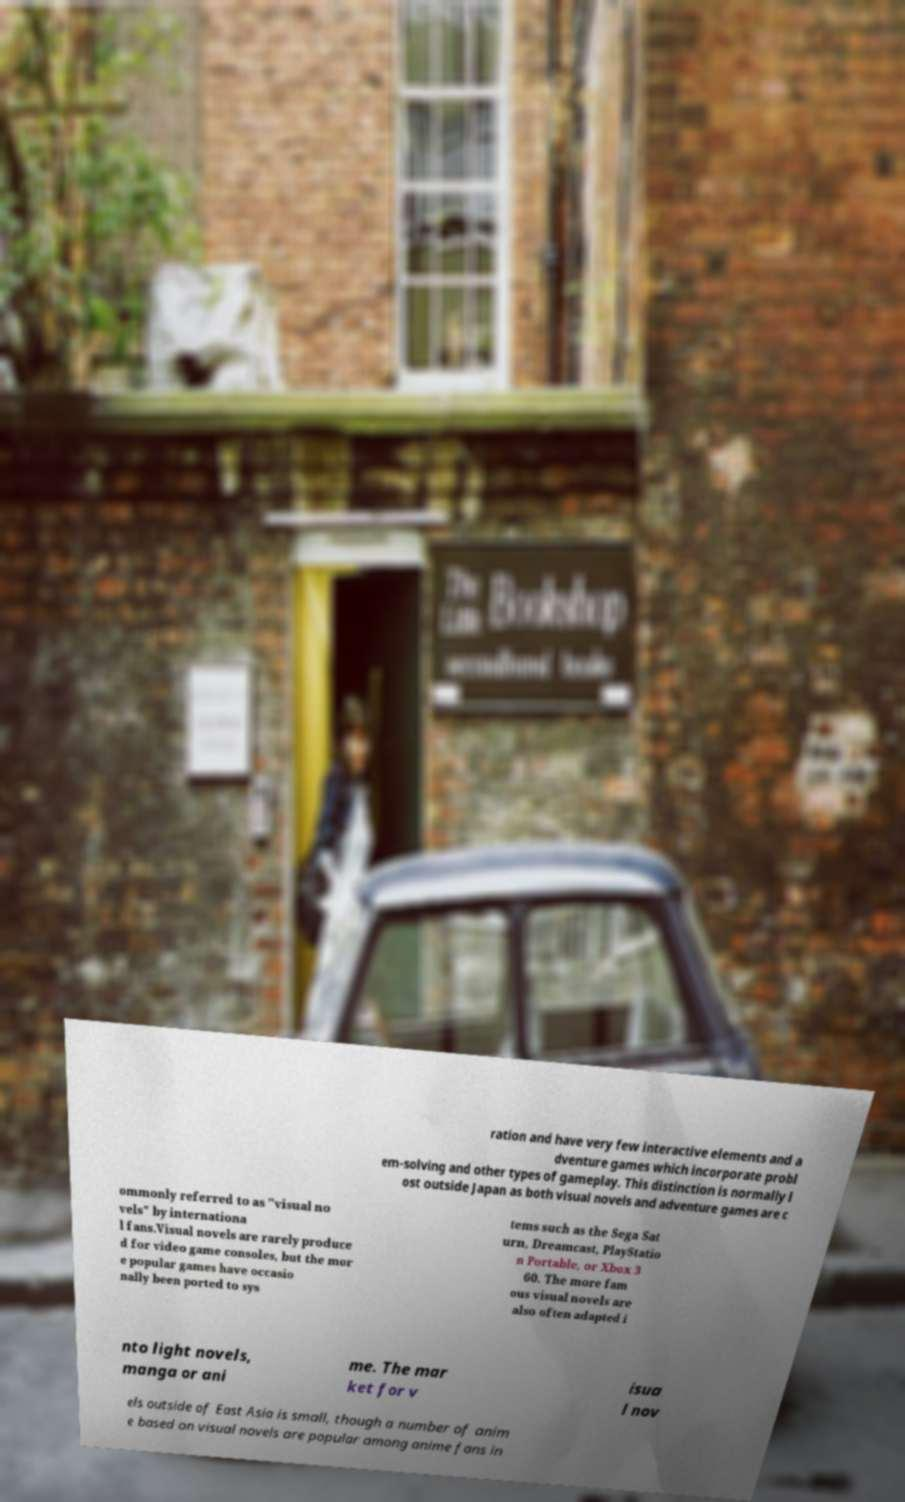Can you read and provide the text displayed in the image?This photo seems to have some interesting text. Can you extract and type it out for me? ration and have very few interactive elements and a dventure games which incorporate probl em-solving and other types of gameplay. This distinction is normally l ost outside Japan as both visual novels and adventure games are c ommonly referred to as "visual no vels" by internationa l fans.Visual novels are rarely produce d for video game consoles, but the mor e popular games have occasio nally been ported to sys tems such as the Sega Sat urn, Dreamcast, PlayStatio n Portable, or Xbox 3 60. The more fam ous visual novels are also often adapted i nto light novels, manga or ani me. The mar ket for v isua l nov els outside of East Asia is small, though a number of anim e based on visual novels are popular among anime fans in 